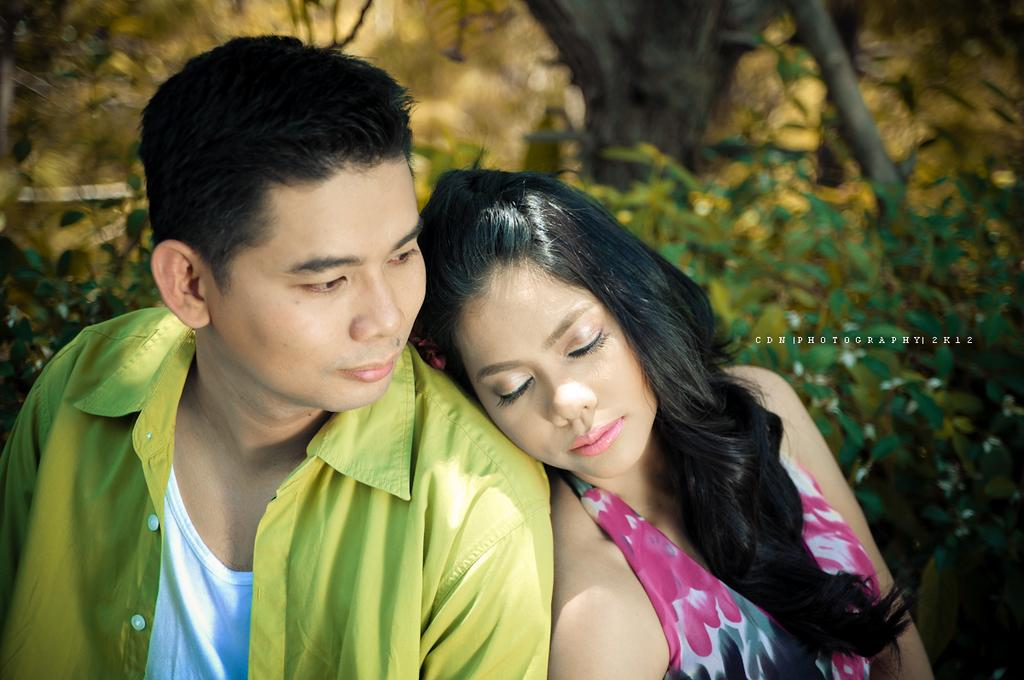What is the man in the image wearing? The man in the image is wearing a green shirt. What is the woman in the image wearing? The woman in the image is wearing a pink dress. What can be seen in the background of the image? There are trees visible in the background of the image. Where is the text located in the image? The text is on the right side of the image. What rule is being enforced by the man in the image? There is no indication in the image that the man is enforcing any rules. Can you tell me how deep the water is for the woman to swim in the image? There is no water present in the image, so it is not possible to determine the depth for swimming. 